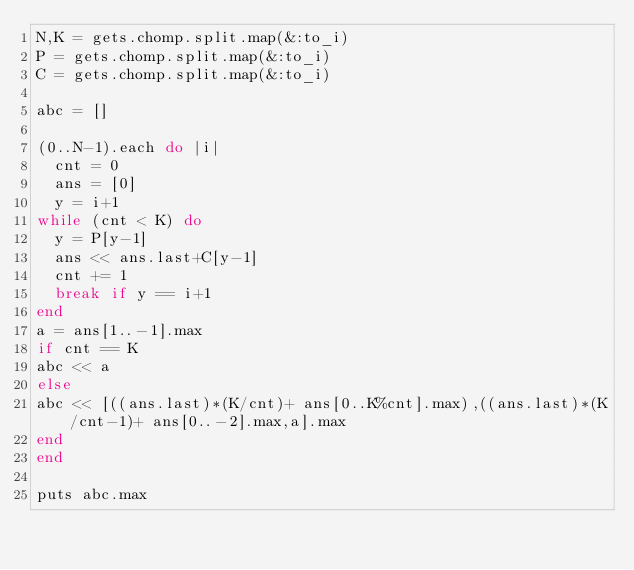<code> <loc_0><loc_0><loc_500><loc_500><_Ruby_>N,K = gets.chomp.split.map(&:to_i)
P = gets.chomp.split.map(&:to_i)
C = gets.chomp.split.map(&:to_i)

abc = []

(0..N-1).each do |i|
  cnt = 0
  ans = [0]
  y = i+1
while (cnt < K) do
  y = P[y-1]
  ans << ans.last+C[y-1]
  cnt += 1
  break if y == i+1
end
a = ans[1..-1].max
if cnt == K
abc << a
else
abc << [((ans.last)*(K/cnt)+ ans[0..K%cnt].max),((ans.last)*(K/cnt-1)+ ans[0..-2].max,a].max 
end
end

puts abc.max



  
  


</code> 